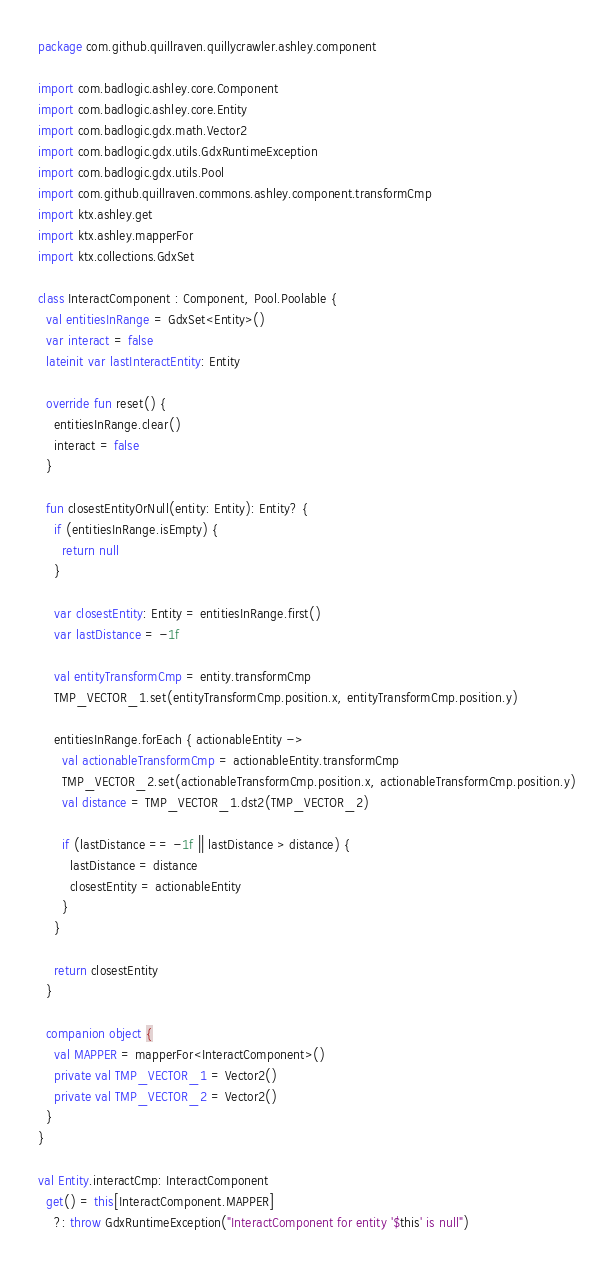<code> <loc_0><loc_0><loc_500><loc_500><_Kotlin_>package com.github.quillraven.quillycrawler.ashley.component

import com.badlogic.ashley.core.Component
import com.badlogic.ashley.core.Entity
import com.badlogic.gdx.math.Vector2
import com.badlogic.gdx.utils.GdxRuntimeException
import com.badlogic.gdx.utils.Pool
import com.github.quillraven.commons.ashley.component.transformCmp
import ktx.ashley.get
import ktx.ashley.mapperFor
import ktx.collections.GdxSet

class InteractComponent : Component, Pool.Poolable {
  val entitiesInRange = GdxSet<Entity>()
  var interact = false
  lateinit var lastInteractEntity: Entity

  override fun reset() {
    entitiesInRange.clear()
    interact = false
  }

  fun closestEntityOrNull(entity: Entity): Entity? {
    if (entitiesInRange.isEmpty) {
      return null
    }

    var closestEntity: Entity = entitiesInRange.first()
    var lastDistance = -1f

    val entityTransformCmp = entity.transformCmp
    TMP_VECTOR_1.set(entityTransformCmp.position.x, entityTransformCmp.position.y)

    entitiesInRange.forEach { actionableEntity ->
      val actionableTransformCmp = actionableEntity.transformCmp
      TMP_VECTOR_2.set(actionableTransformCmp.position.x, actionableTransformCmp.position.y)
      val distance = TMP_VECTOR_1.dst2(TMP_VECTOR_2)

      if (lastDistance == -1f || lastDistance > distance) {
        lastDistance = distance
        closestEntity = actionableEntity
      }
    }

    return closestEntity
  }

  companion object {
    val MAPPER = mapperFor<InteractComponent>()
    private val TMP_VECTOR_1 = Vector2()
    private val TMP_VECTOR_2 = Vector2()
  }
}

val Entity.interactCmp: InteractComponent
  get() = this[InteractComponent.MAPPER]
    ?: throw GdxRuntimeException("InteractComponent for entity '$this' is null")
</code> 